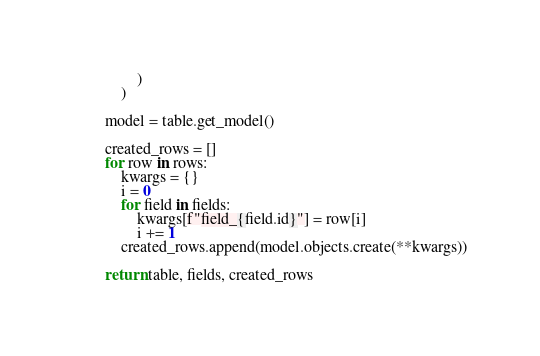<code> <loc_0><loc_0><loc_500><loc_500><_Python_>                )
            )

        model = table.get_model()

        created_rows = []
        for row in rows:
            kwargs = {}
            i = 0
            for field in fields:
                kwargs[f"field_{field.id}"] = row[i]
                i += 1
            created_rows.append(model.objects.create(**kwargs))

        return table, fields, created_rows
</code> 